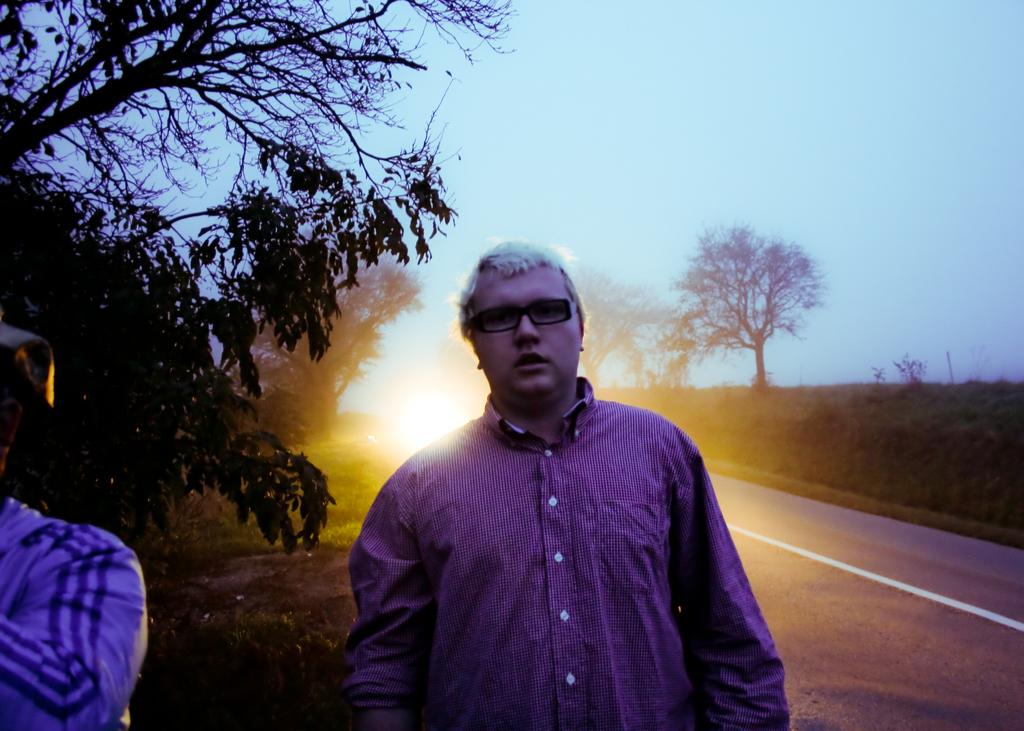What are the men in the image doing? The men in the image are standing on the road. What can be seen in the background of the image? There is grass, trees, and the sky visible in the background of the image. What type of drain can be seen in the image? There is no drain present in the image. What activity are the men engaged in while rubbing their hands together? The men are not rubbing their hands together in the image; they are simply standing on the road. 